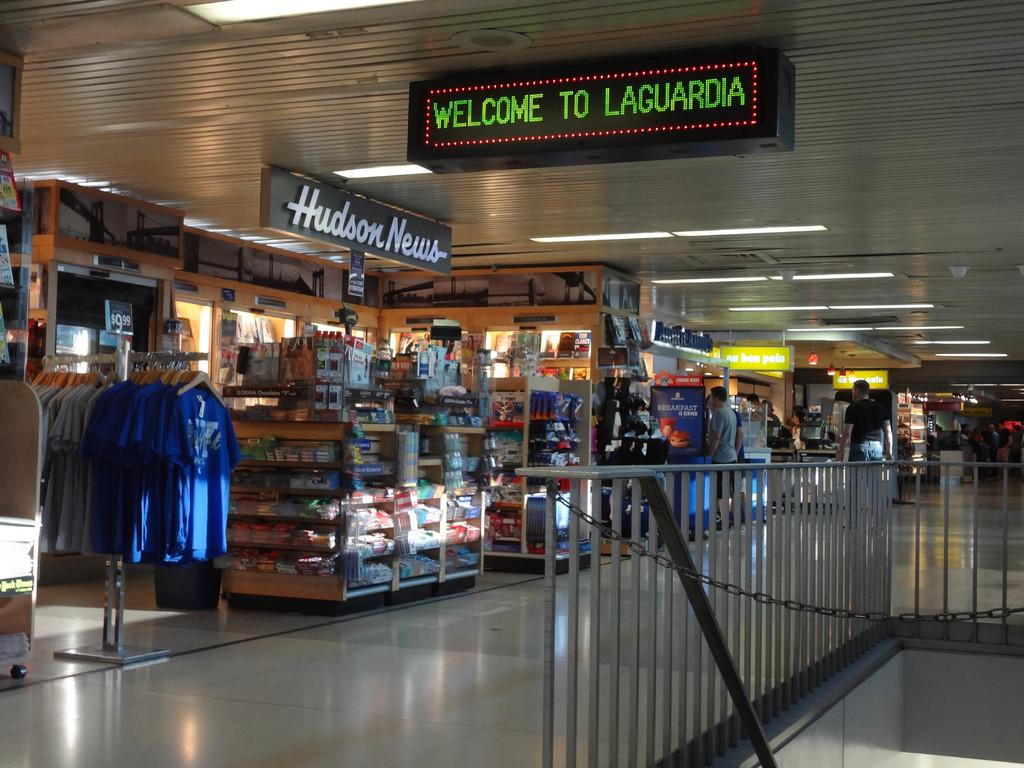<image>
Summarize the visual content of the image. A Hudson News gift shop at the Laguardia airport. 